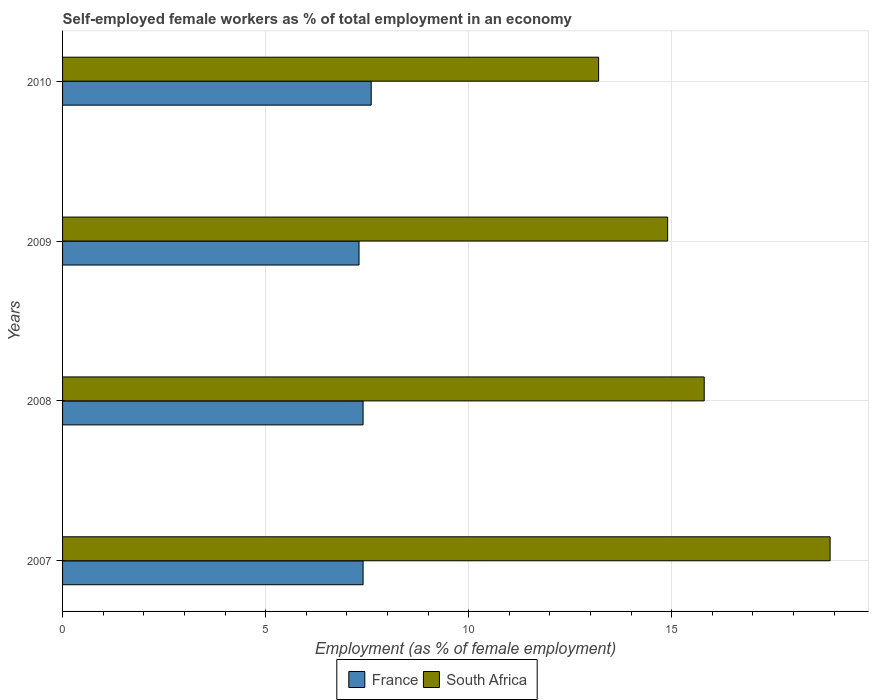Are the number of bars on each tick of the Y-axis equal?
Provide a succinct answer. Yes. How many bars are there on the 4th tick from the bottom?
Provide a succinct answer. 2. What is the label of the 2nd group of bars from the top?
Your answer should be compact. 2009. In how many cases, is the number of bars for a given year not equal to the number of legend labels?
Offer a very short reply. 0. What is the percentage of self-employed female workers in South Africa in 2007?
Offer a very short reply. 18.9. Across all years, what is the maximum percentage of self-employed female workers in South Africa?
Ensure brevity in your answer.  18.9. Across all years, what is the minimum percentage of self-employed female workers in France?
Your answer should be very brief. 7.3. In which year was the percentage of self-employed female workers in France maximum?
Your answer should be very brief. 2010. What is the total percentage of self-employed female workers in South Africa in the graph?
Provide a short and direct response. 62.8. What is the difference between the percentage of self-employed female workers in South Africa in 2007 and that in 2009?
Make the answer very short. 4. What is the difference between the percentage of self-employed female workers in France in 2010 and the percentage of self-employed female workers in South Africa in 2007?
Your answer should be compact. -11.3. What is the average percentage of self-employed female workers in France per year?
Keep it short and to the point. 7.43. In the year 2010, what is the difference between the percentage of self-employed female workers in South Africa and percentage of self-employed female workers in France?
Your answer should be very brief. 5.6. In how many years, is the percentage of self-employed female workers in South Africa greater than 10 %?
Your answer should be compact. 4. What is the ratio of the percentage of self-employed female workers in France in 2009 to that in 2010?
Your answer should be very brief. 0.96. What is the difference between the highest and the second highest percentage of self-employed female workers in South Africa?
Offer a very short reply. 3.1. What is the difference between the highest and the lowest percentage of self-employed female workers in South Africa?
Provide a succinct answer. 5.7. What does the 1st bar from the top in 2010 represents?
Give a very brief answer. South Africa. What is the difference between two consecutive major ticks on the X-axis?
Offer a very short reply. 5. Are the values on the major ticks of X-axis written in scientific E-notation?
Your response must be concise. No. Does the graph contain grids?
Give a very brief answer. Yes. Where does the legend appear in the graph?
Keep it short and to the point. Bottom center. How are the legend labels stacked?
Give a very brief answer. Horizontal. What is the title of the graph?
Keep it short and to the point. Self-employed female workers as % of total employment in an economy. Does "Cayman Islands" appear as one of the legend labels in the graph?
Your answer should be compact. No. What is the label or title of the X-axis?
Ensure brevity in your answer.  Employment (as % of female employment). What is the Employment (as % of female employment) of France in 2007?
Ensure brevity in your answer.  7.4. What is the Employment (as % of female employment) in South Africa in 2007?
Ensure brevity in your answer.  18.9. What is the Employment (as % of female employment) of France in 2008?
Provide a succinct answer. 7.4. What is the Employment (as % of female employment) in South Africa in 2008?
Offer a very short reply. 15.8. What is the Employment (as % of female employment) in France in 2009?
Ensure brevity in your answer.  7.3. What is the Employment (as % of female employment) of South Africa in 2009?
Make the answer very short. 14.9. What is the Employment (as % of female employment) in France in 2010?
Your answer should be very brief. 7.6. What is the Employment (as % of female employment) in South Africa in 2010?
Your answer should be compact. 13.2. Across all years, what is the maximum Employment (as % of female employment) in France?
Your answer should be compact. 7.6. Across all years, what is the maximum Employment (as % of female employment) of South Africa?
Provide a short and direct response. 18.9. Across all years, what is the minimum Employment (as % of female employment) of France?
Give a very brief answer. 7.3. Across all years, what is the minimum Employment (as % of female employment) in South Africa?
Make the answer very short. 13.2. What is the total Employment (as % of female employment) of France in the graph?
Offer a very short reply. 29.7. What is the total Employment (as % of female employment) in South Africa in the graph?
Provide a succinct answer. 62.8. What is the difference between the Employment (as % of female employment) of South Africa in 2007 and that in 2008?
Offer a very short reply. 3.1. What is the difference between the Employment (as % of female employment) in France in 2007 and that in 2009?
Your answer should be compact. 0.1. What is the difference between the Employment (as % of female employment) in South Africa in 2007 and that in 2009?
Your response must be concise. 4. What is the difference between the Employment (as % of female employment) in France in 2007 and that in 2010?
Offer a terse response. -0.2. What is the difference between the Employment (as % of female employment) in France in 2008 and that in 2009?
Make the answer very short. 0.1. What is the difference between the Employment (as % of female employment) of France in 2008 and that in 2010?
Offer a very short reply. -0.2. What is the difference between the Employment (as % of female employment) of South Africa in 2009 and that in 2010?
Your response must be concise. 1.7. What is the difference between the Employment (as % of female employment) of France in 2007 and the Employment (as % of female employment) of South Africa in 2008?
Ensure brevity in your answer.  -8.4. What is the average Employment (as % of female employment) of France per year?
Keep it short and to the point. 7.42. What is the average Employment (as % of female employment) of South Africa per year?
Provide a succinct answer. 15.7. In the year 2009, what is the difference between the Employment (as % of female employment) in France and Employment (as % of female employment) in South Africa?
Ensure brevity in your answer.  -7.6. What is the ratio of the Employment (as % of female employment) in France in 2007 to that in 2008?
Offer a very short reply. 1. What is the ratio of the Employment (as % of female employment) in South Africa in 2007 to that in 2008?
Offer a very short reply. 1.2. What is the ratio of the Employment (as % of female employment) in France in 2007 to that in 2009?
Offer a very short reply. 1.01. What is the ratio of the Employment (as % of female employment) in South Africa in 2007 to that in 2009?
Your answer should be very brief. 1.27. What is the ratio of the Employment (as % of female employment) of France in 2007 to that in 2010?
Ensure brevity in your answer.  0.97. What is the ratio of the Employment (as % of female employment) of South Africa in 2007 to that in 2010?
Your answer should be very brief. 1.43. What is the ratio of the Employment (as % of female employment) of France in 2008 to that in 2009?
Keep it short and to the point. 1.01. What is the ratio of the Employment (as % of female employment) in South Africa in 2008 to that in 2009?
Ensure brevity in your answer.  1.06. What is the ratio of the Employment (as % of female employment) in France in 2008 to that in 2010?
Your answer should be compact. 0.97. What is the ratio of the Employment (as % of female employment) in South Africa in 2008 to that in 2010?
Keep it short and to the point. 1.2. What is the ratio of the Employment (as % of female employment) of France in 2009 to that in 2010?
Offer a very short reply. 0.96. What is the ratio of the Employment (as % of female employment) of South Africa in 2009 to that in 2010?
Your response must be concise. 1.13. What is the difference between the highest and the lowest Employment (as % of female employment) of France?
Your answer should be very brief. 0.3. 